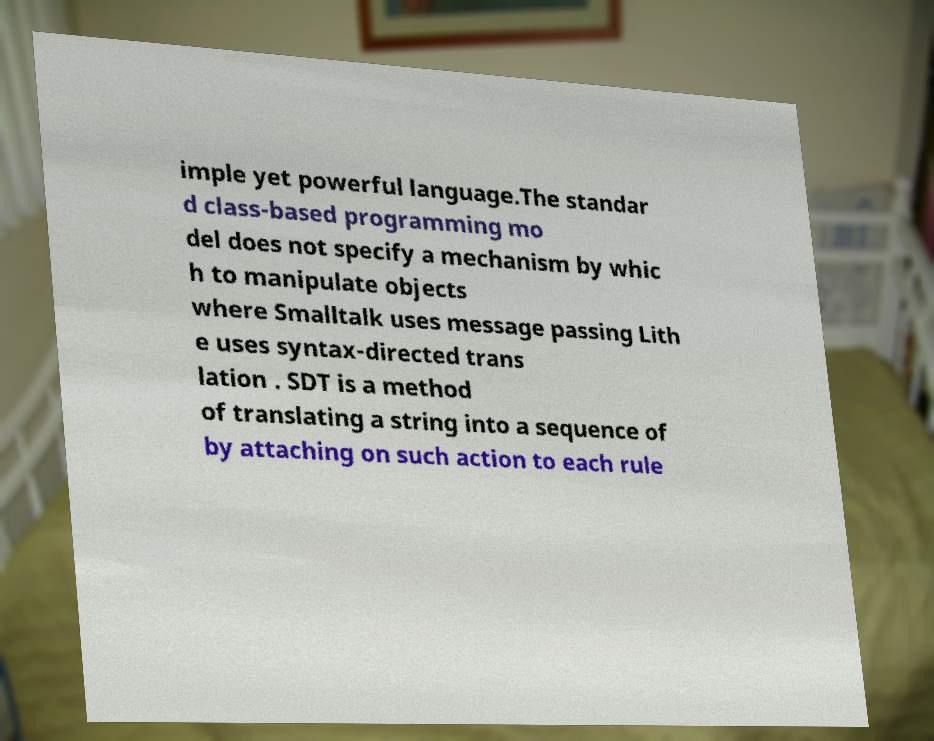For documentation purposes, I need the text within this image transcribed. Could you provide that? imple yet powerful language.The standar d class-based programming mo del does not specify a mechanism by whic h to manipulate objects where Smalltalk uses message passing Lith e uses syntax-directed trans lation . SDT is a method of translating a string into a sequence of by attaching on such action to each rule 